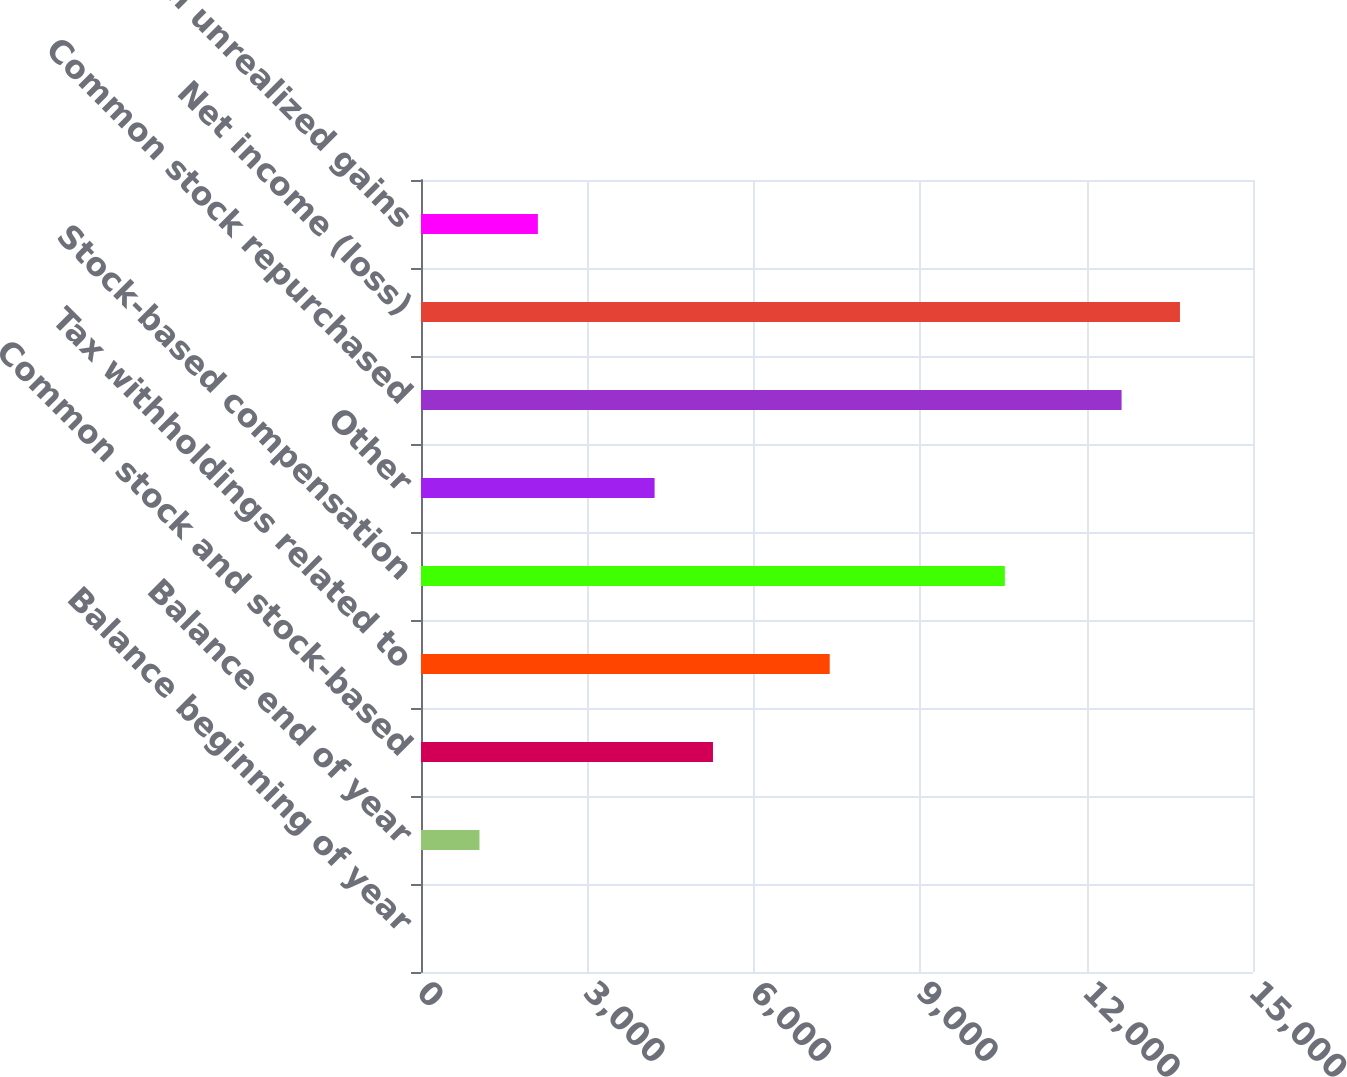Convert chart. <chart><loc_0><loc_0><loc_500><loc_500><bar_chart><fcel>Balance beginning of year<fcel>Balance end of year<fcel>Common stock and stock-based<fcel>Tax withholdings related to<fcel>Stock-based compensation<fcel>Other<fcel>Common stock repurchased<fcel>Net income (loss)<fcel>Change in unrealized gains<nl><fcel>2<fcel>1054.4<fcel>5264<fcel>7368.8<fcel>10526<fcel>4211.6<fcel>12630.8<fcel>13683.2<fcel>2106.8<nl></chart> 